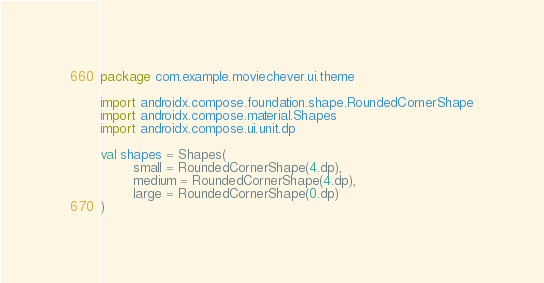<code> <loc_0><loc_0><loc_500><loc_500><_Kotlin_>package com.example.moviechever.ui.theme

import androidx.compose.foundation.shape.RoundedCornerShape
import androidx.compose.material.Shapes
import androidx.compose.ui.unit.dp

val shapes = Shapes(
        small = RoundedCornerShape(4.dp),
        medium = RoundedCornerShape(4.dp),
        large = RoundedCornerShape(0.dp)
)</code> 